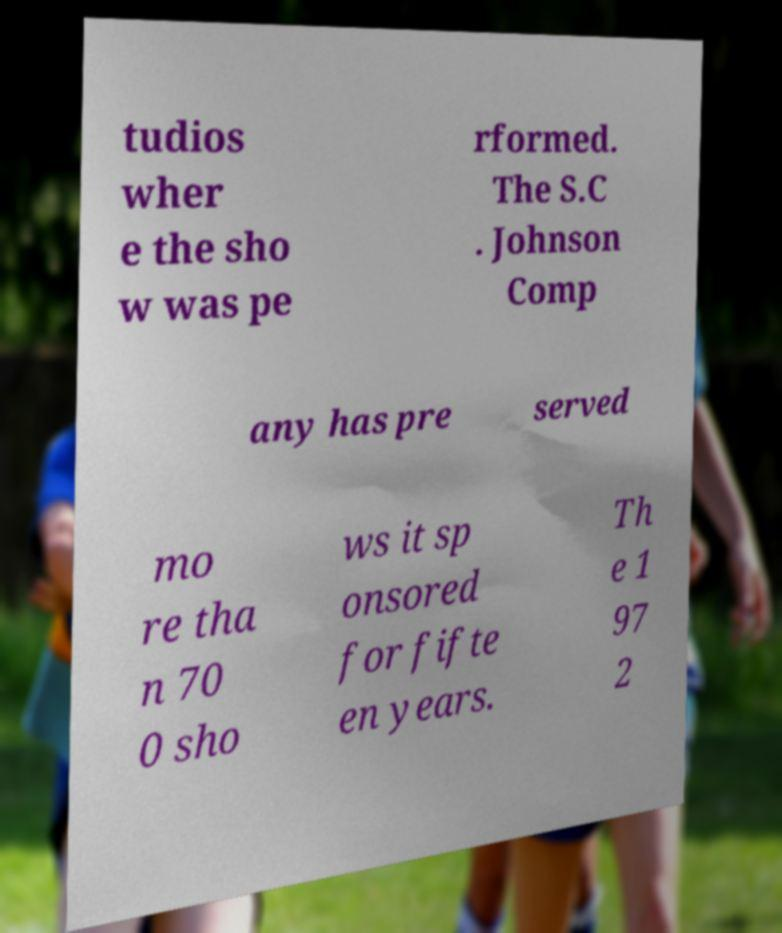For documentation purposes, I need the text within this image transcribed. Could you provide that? tudios wher e the sho w was pe rformed. The S.C . Johnson Comp any has pre served mo re tha n 70 0 sho ws it sp onsored for fifte en years. Th e 1 97 2 